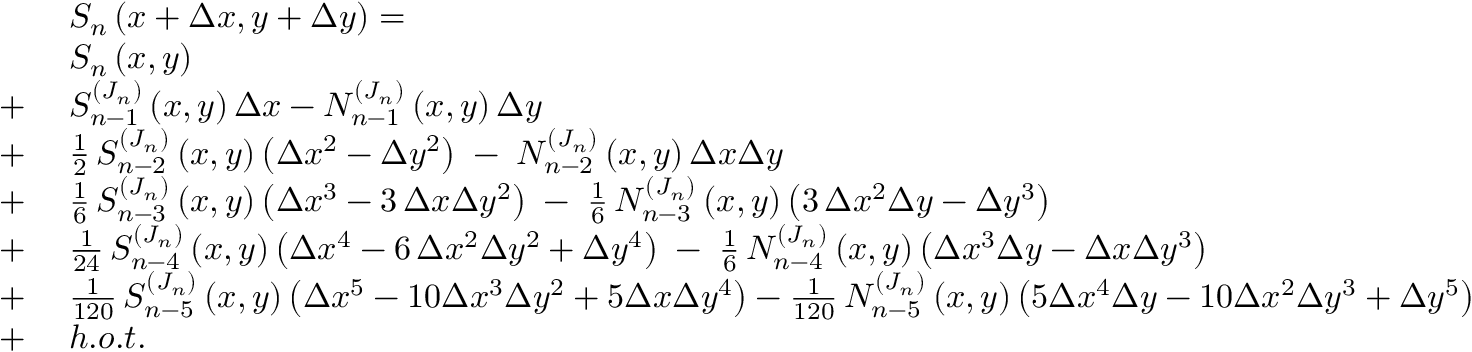Convert formula to latex. <formula><loc_0><loc_0><loc_500><loc_500>\begin{array} { r l } & { S _ { n } \left ( x + \Delta x , y + \Delta y \right ) = } \\ & { S _ { n } \left ( x , y \right ) } \\ { + \, } & { S _ { n - 1 } ^ { ( J _ { n } ) } \left ( x , y \right ) \Delta x - N _ { n - 1 } ^ { ( J _ { n } ) } \left ( x , y \right ) \Delta y } \\ { + \, } & { \frac { 1 } { 2 } \, S _ { n - 2 } ^ { ( J _ { n } ) } \left ( x , y \right ) \left ( \Delta x ^ { 2 } - \Delta y ^ { 2 } \right ) \, - \, N _ { n - 2 } ^ { ( J _ { n } ) } \left ( x , y \right ) \Delta x \Delta y } \\ { + \, } & { \frac { 1 } { 6 } \, S _ { n - 3 } ^ { ( J _ { n } ) } \left ( x , y \right ) \left ( \Delta x ^ { 3 } - 3 \, \Delta x \Delta y ^ { 2 } \right ) \, - \, \frac { 1 } { 6 } \, N _ { n - 3 } ^ { ( J _ { n } ) } \left ( x , y \right ) \left ( 3 \, \Delta x ^ { 2 } \Delta y - \Delta y ^ { 3 } \right ) } \\ { + \, } & { \frac { 1 } { 2 4 } \, S _ { n - 4 } ^ { ( J _ { n } ) } \left ( x , y \right ) \left ( \Delta x ^ { 4 } - 6 \, \Delta x ^ { 2 } \Delta y ^ { 2 } + \Delta y ^ { 4 } \right ) \, - \, \frac { 1 } { 6 } \, N _ { n - 4 } ^ { ( J _ { n } ) } \left ( x , y \right ) \left ( \Delta x ^ { 3 } \Delta y - \Delta x \Delta y ^ { 3 } \right ) } \\ { + \, } & { \frac { 1 } { 1 2 0 } \, S _ { n - 5 } ^ { ( J _ { n } ) } \left ( x , y \right ) \left ( \Delta x ^ { 5 } - 1 0 \Delta x ^ { 3 } \Delta y ^ { 2 } + 5 \Delta x \Delta y ^ { 4 } \right ) - \frac { 1 } { 1 2 0 } \, N _ { n - 5 } ^ { ( J _ { n } ) } \left ( x , y \right ) \left ( 5 \Delta x ^ { 4 } \Delta y - 1 0 \Delta x ^ { 2 } \Delta y ^ { 3 } + \Delta y ^ { 5 } \right ) } \\ { + \, } & { h . o . t . } \end{array}</formula> 